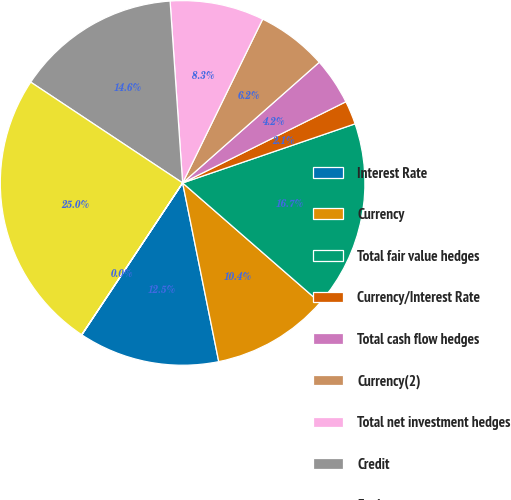<chart> <loc_0><loc_0><loc_500><loc_500><pie_chart><fcel>Interest Rate<fcel>Currency<fcel>Total fair value hedges<fcel>Currency/Interest Rate<fcel>Total cash flow hedges<fcel>Currency(2)<fcel>Total net investment hedges<fcel>Credit<fcel>Equity<fcel>Commodity<nl><fcel>12.5%<fcel>10.42%<fcel>16.66%<fcel>2.09%<fcel>4.17%<fcel>6.25%<fcel>8.33%<fcel>14.58%<fcel>24.99%<fcel>0.01%<nl></chart> 